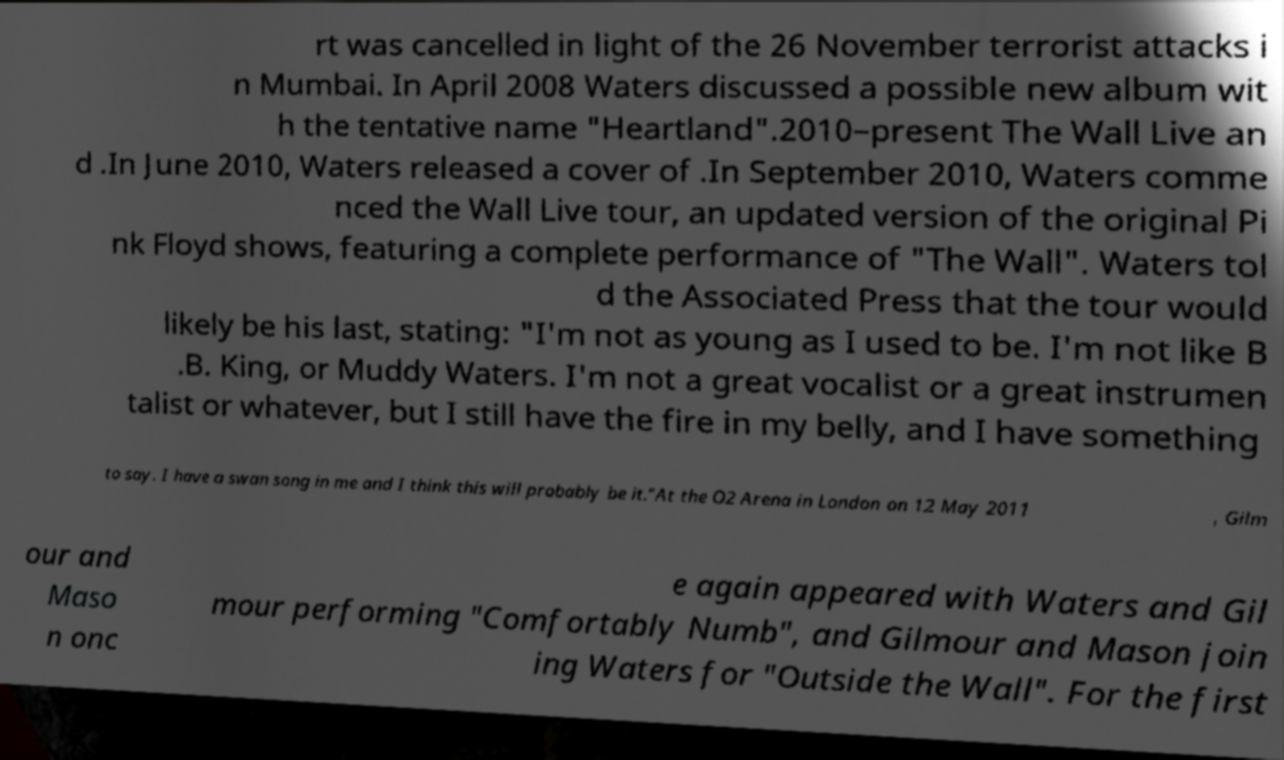Could you extract and type out the text from this image? rt was cancelled in light of the 26 November terrorist attacks i n Mumbai. In April 2008 Waters discussed a possible new album wit h the tentative name "Heartland".2010–present The Wall Live an d .In June 2010, Waters released a cover of .In September 2010, Waters comme nced the Wall Live tour, an updated version of the original Pi nk Floyd shows, featuring a complete performance of "The Wall". Waters tol d the Associated Press that the tour would likely be his last, stating: "I'm not as young as I used to be. I'm not like B .B. King, or Muddy Waters. I'm not a great vocalist or a great instrumen talist or whatever, but I still have the fire in my belly, and I have something to say. I have a swan song in me and I think this will probably be it."At the O2 Arena in London on 12 May 2011 , Gilm our and Maso n onc e again appeared with Waters and Gil mour performing "Comfortably Numb", and Gilmour and Mason join ing Waters for "Outside the Wall". For the first 